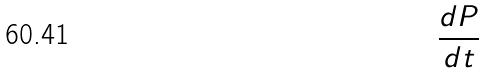<formula> <loc_0><loc_0><loc_500><loc_500>\frac { d P } { d t }</formula> 